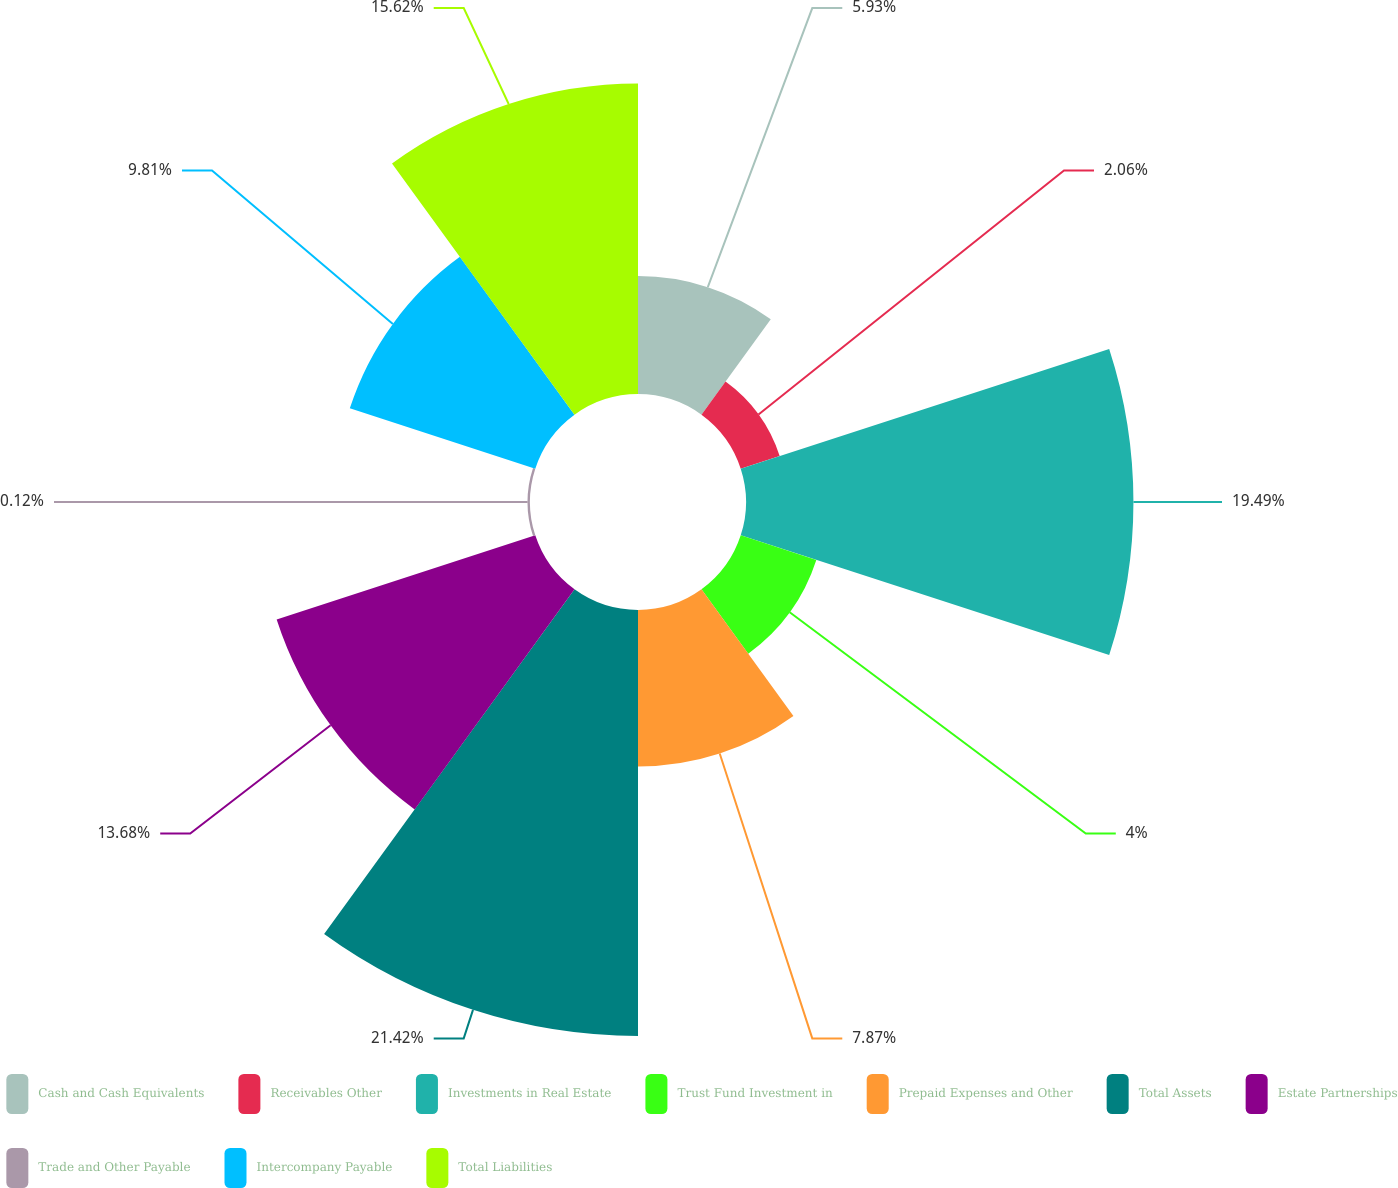Convert chart. <chart><loc_0><loc_0><loc_500><loc_500><pie_chart><fcel>Cash and Cash Equivalents<fcel>Receivables Other<fcel>Investments in Real Estate<fcel>Trust Fund Investment in<fcel>Prepaid Expenses and Other<fcel>Total Assets<fcel>Estate Partnerships<fcel>Trade and Other Payable<fcel>Intercompany Payable<fcel>Total Liabilities<nl><fcel>5.93%<fcel>2.06%<fcel>19.49%<fcel>4.0%<fcel>7.87%<fcel>21.43%<fcel>13.68%<fcel>0.12%<fcel>9.81%<fcel>15.62%<nl></chart> 